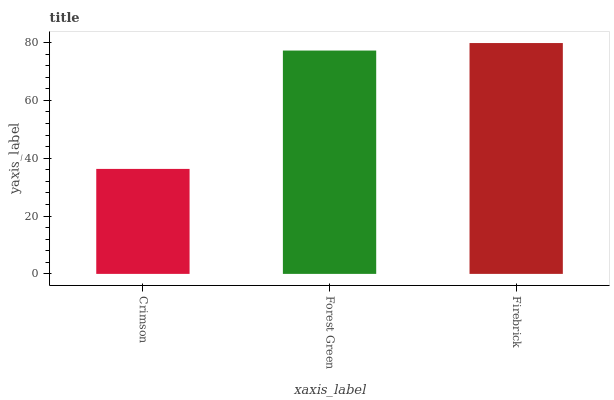Is Crimson the minimum?
Answer yes or no. Yes. Is Firebrick the maximum?
Answer yes or no. Yes. Is Forest Green the minimum?
Answer yes or no. No. Is Forest Green the maximum?
Answer yes or no. No. Is Forest Green greater than Crimson?
Answer yes or no. Yes. Is Crimson less than Forest Green?
Answer yes or no. Yes. Is Crimson greater than Forest Green?
Answer yes or no. No. Is Forest Green less than Crimson?
Answer yes or no. No. Is Forest Green the high median?
Answer yes or no. Yes. Is Forest Green the low median?
Answer yes or no. Yes. Is Firebrick the high median?
Answer yes or no. No. Is Crimson the low median?
Answer yes or no. No. 